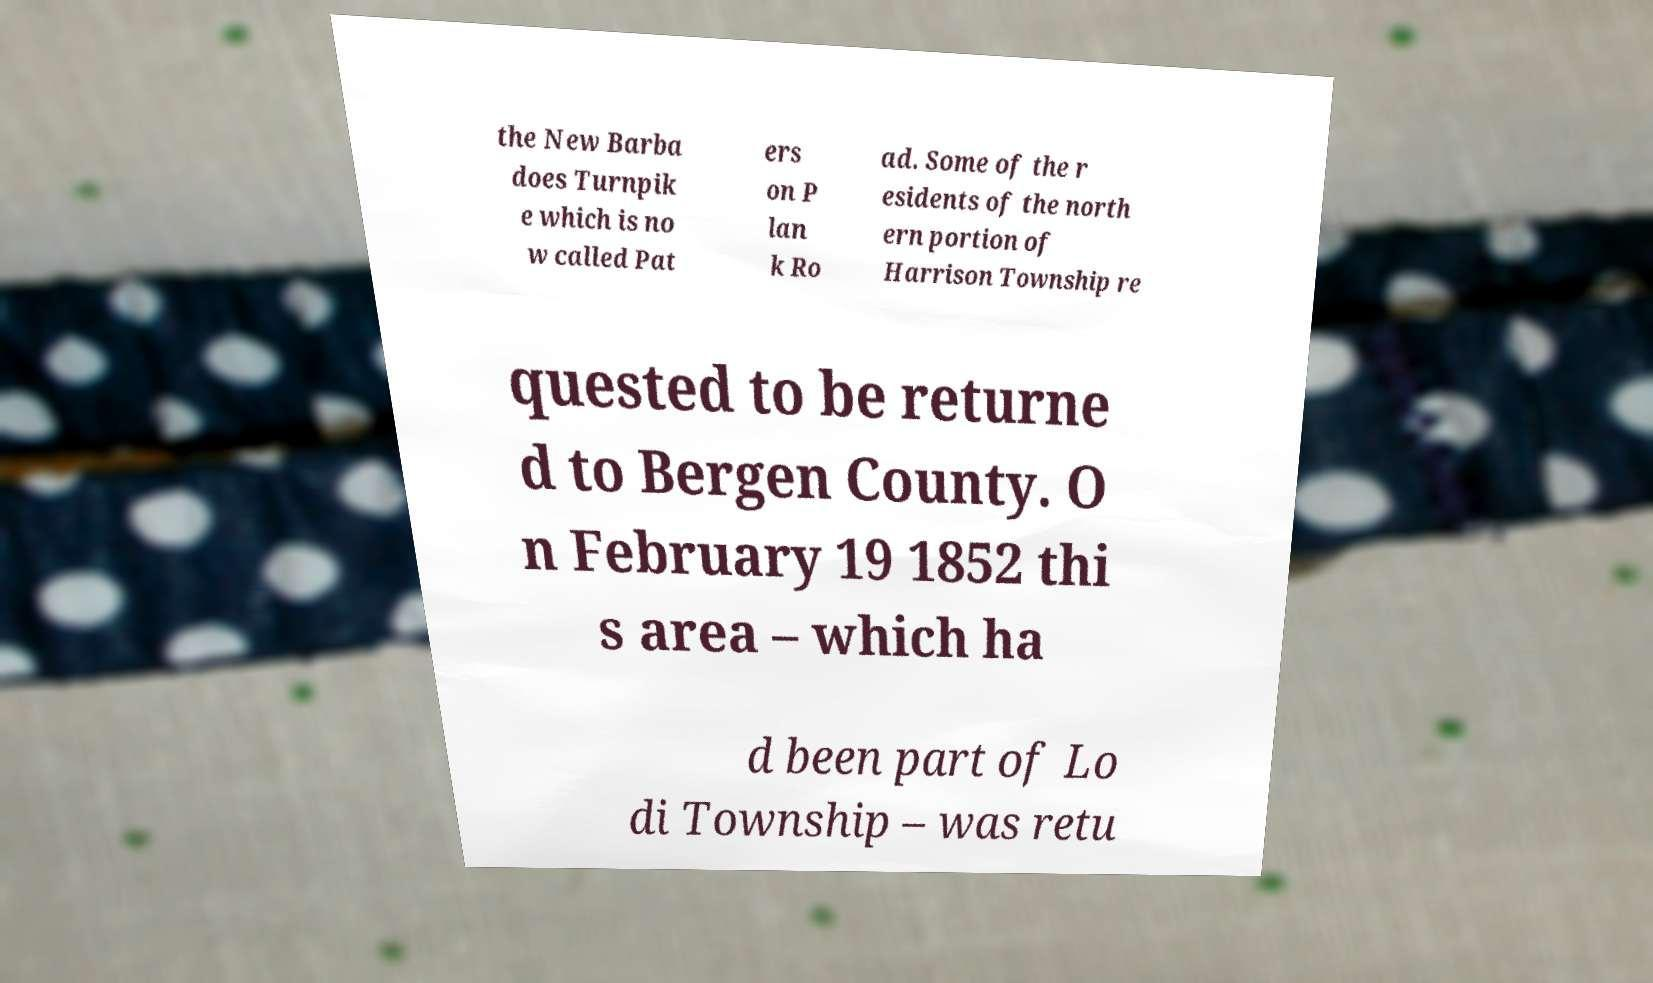I need the written content from this picture converted into text. Can you do that? the New Barba does Turnpik e which is no w called Pat ers on P lan k Ro ad. Some of the r esidents of the north ern portion of Harrison Township re quested to be returne d to Bergen County. O n February 19 1852 thi s area – which ha d been part of Lo di Township – was retu 